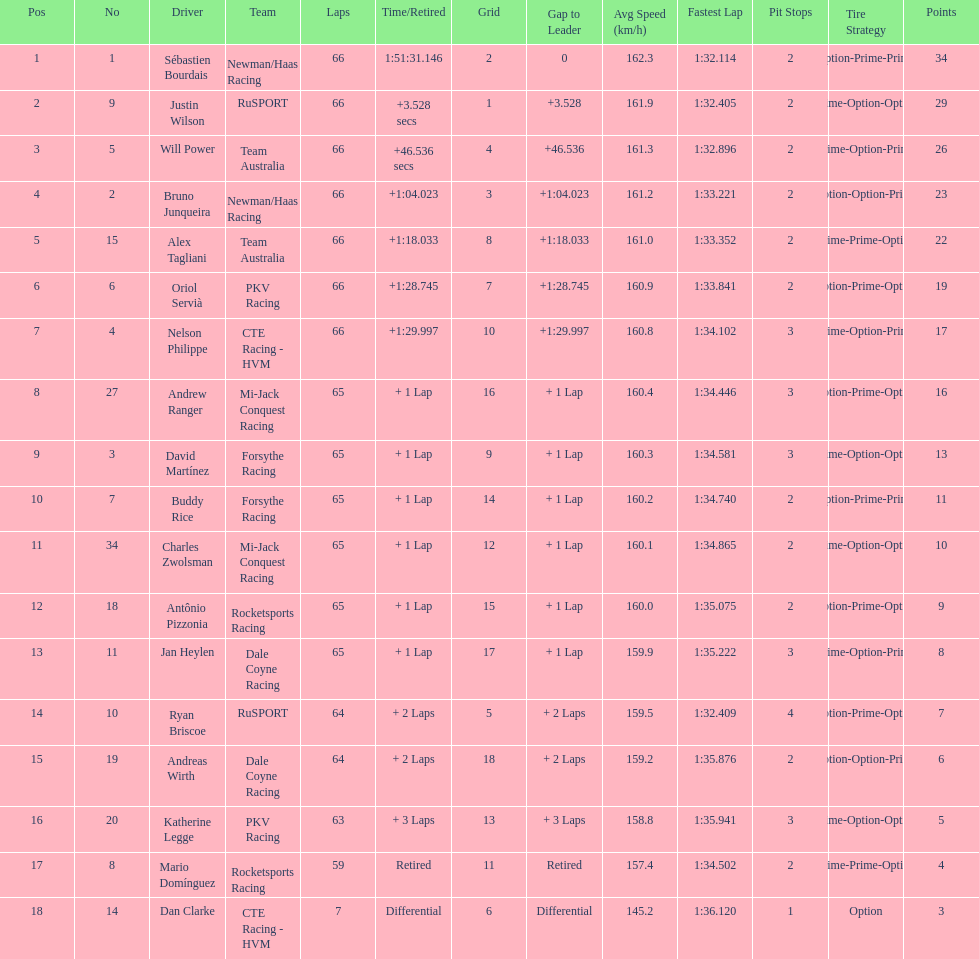Which racer has a number that matches their standing? Sébastien Bourdais. 